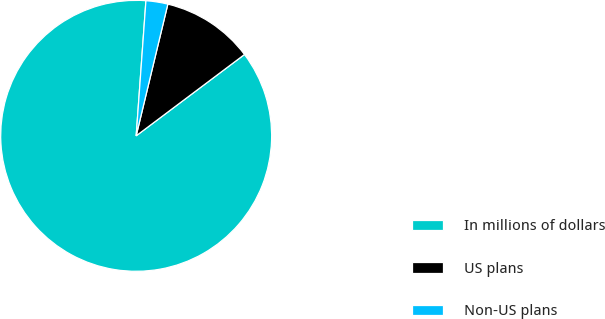<chart> <loc_0><loc_0><loc_500><loc_500><pie_chart><fcel>In millions of dollars<fcel>US plans<fcel>Non-US plans<nl><fcel>86.39%<fcel>10.99%<fcel>2.61%<nl></chart> 